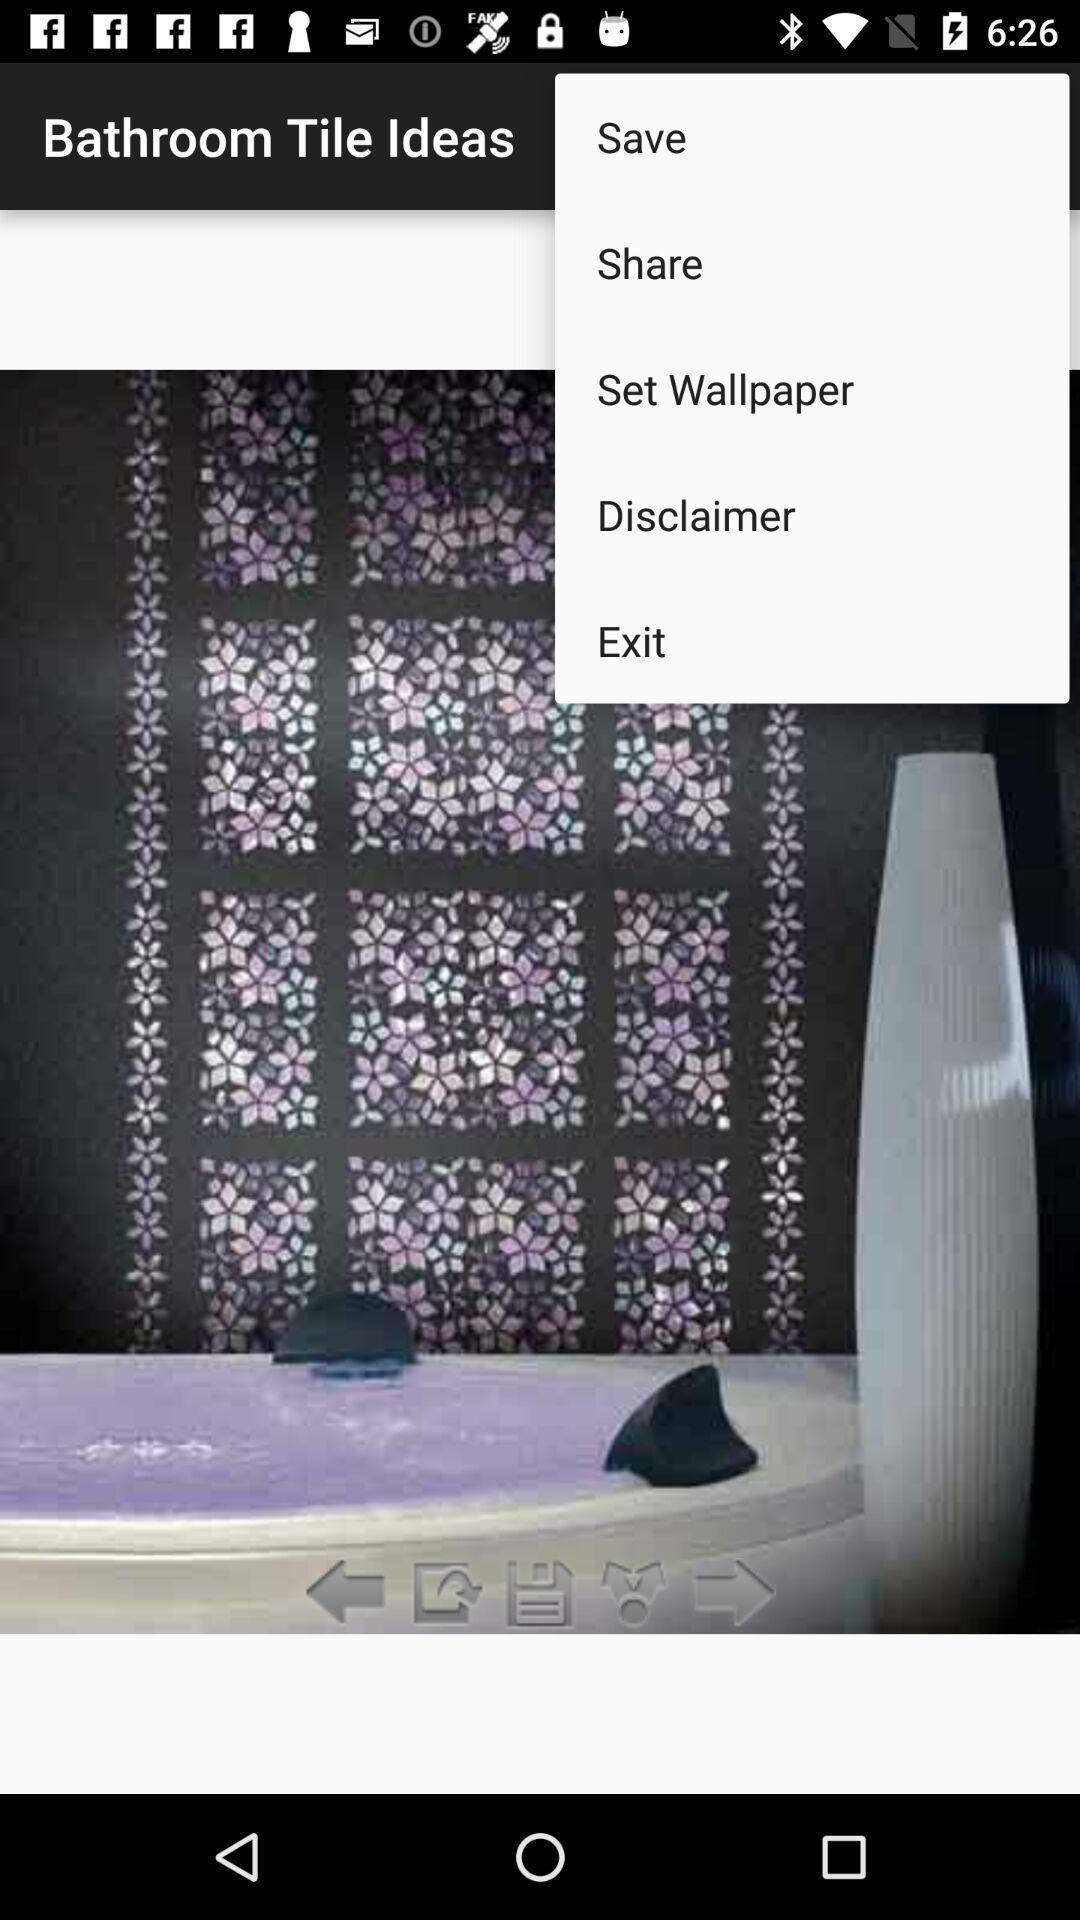Give me a narrative description of this picture. Pop up page displayed includes various options of decor app. 